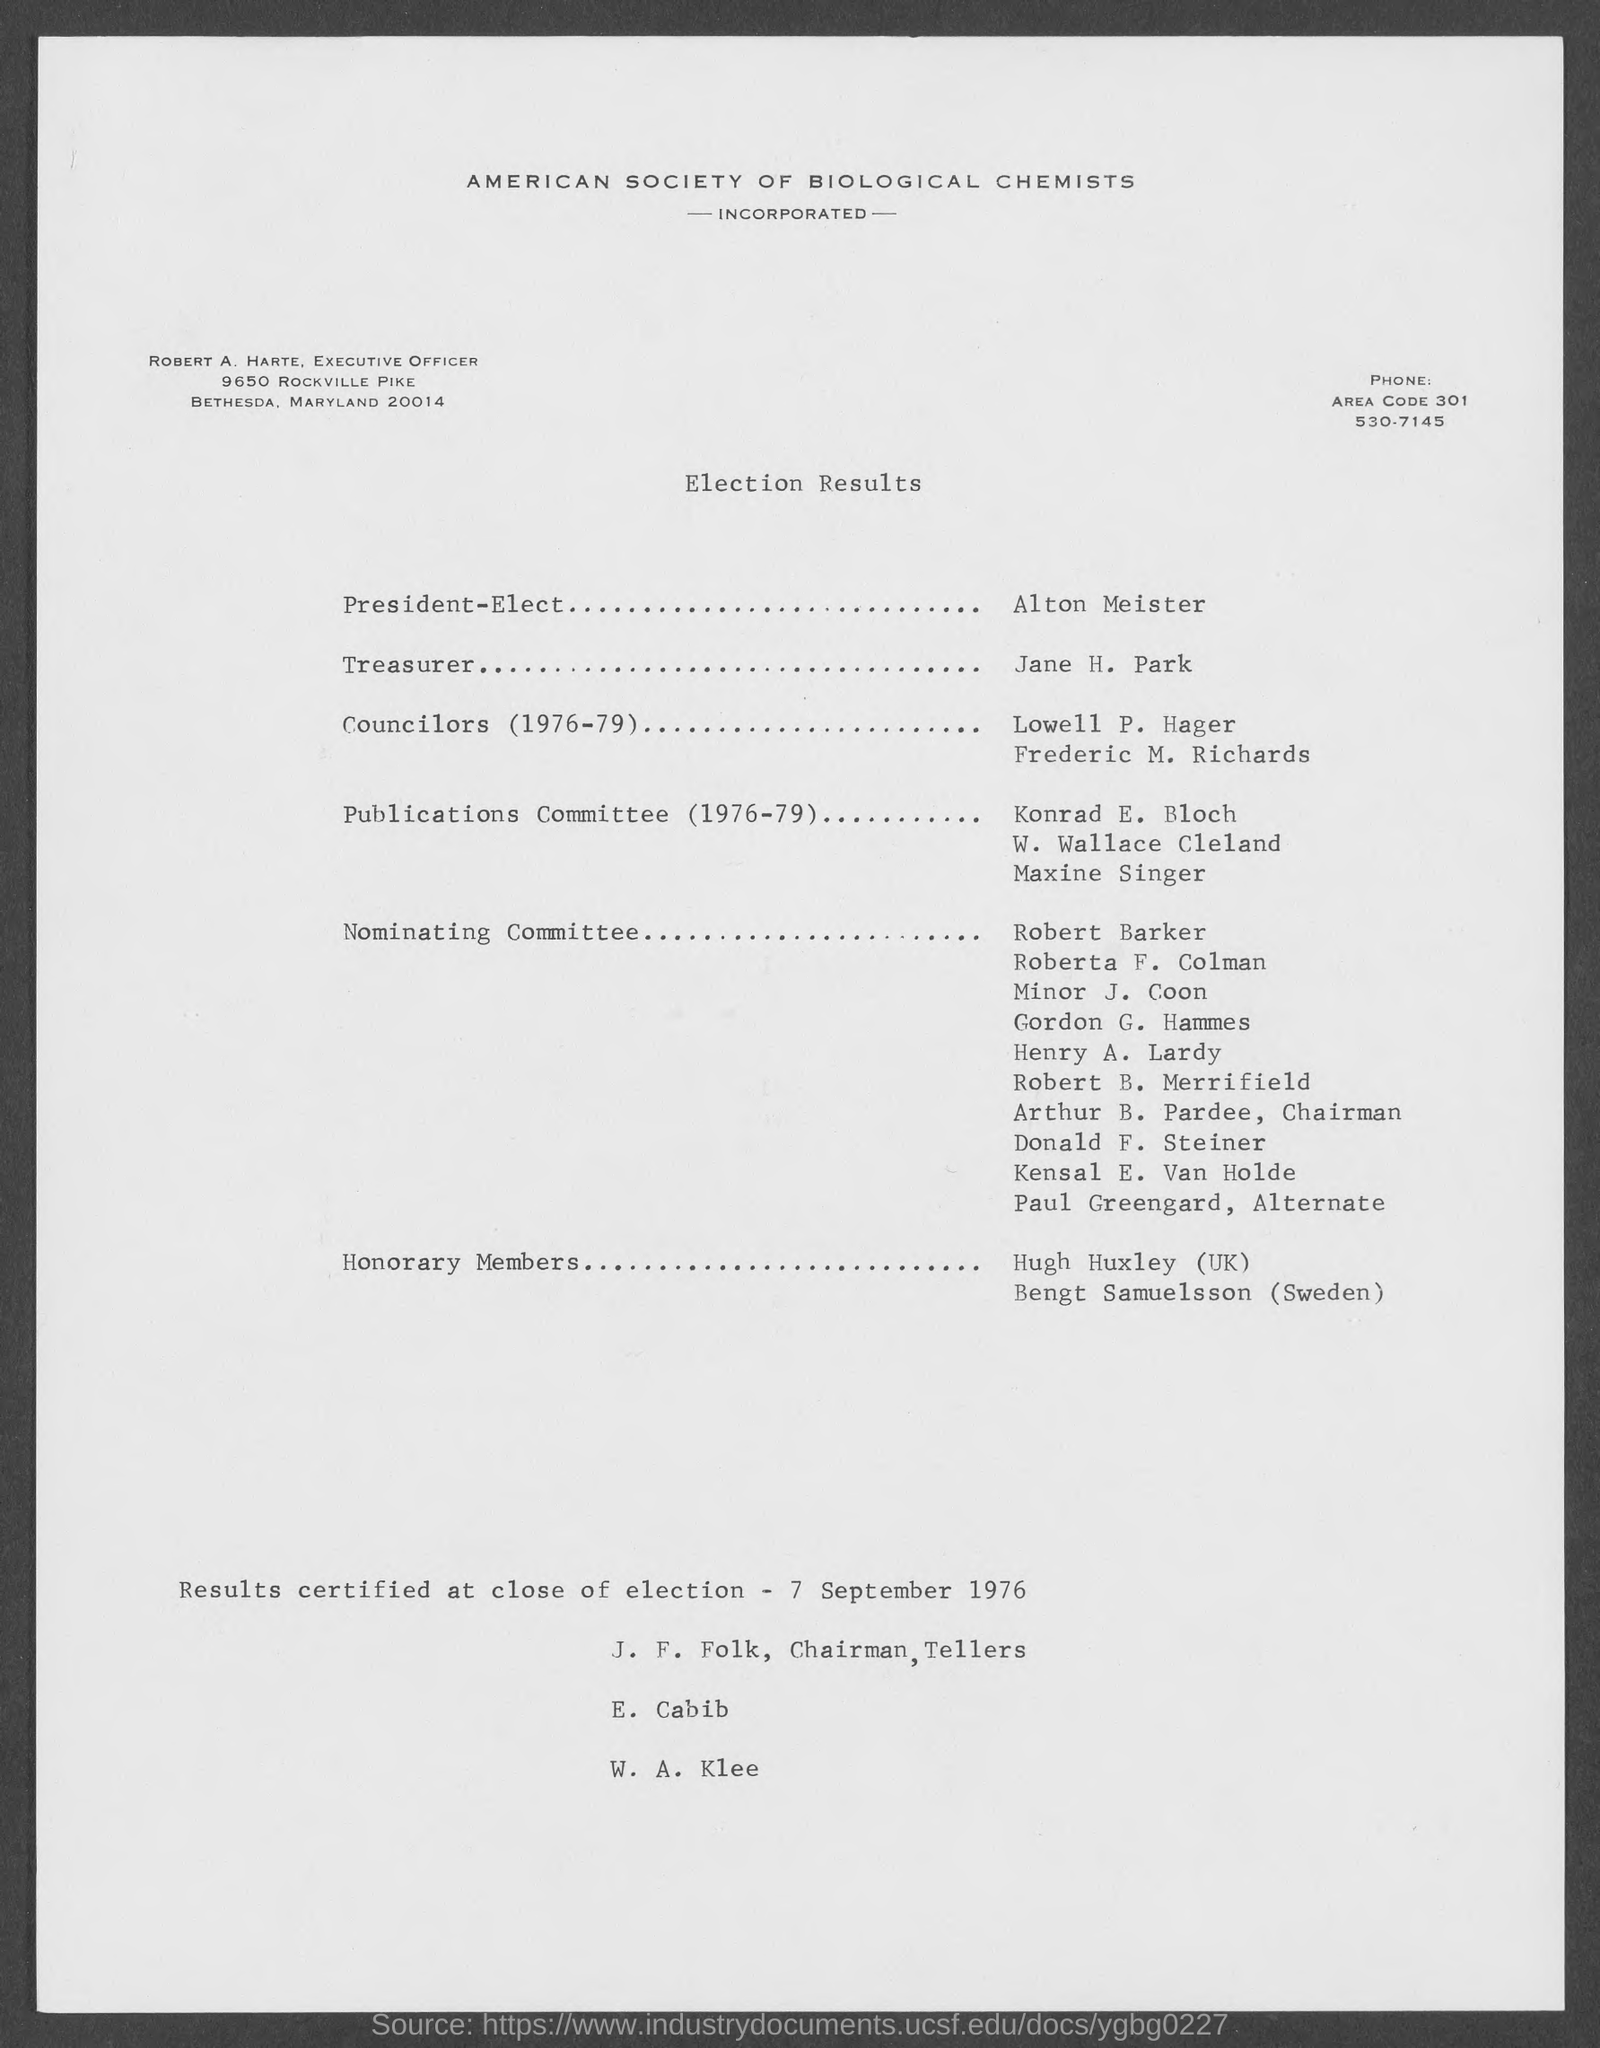Who is the President-Elect?
Ensure brevity in your answer.  Alton Meister. Who is the Treasurer?
Your response must be concise. Jane H. Park. 